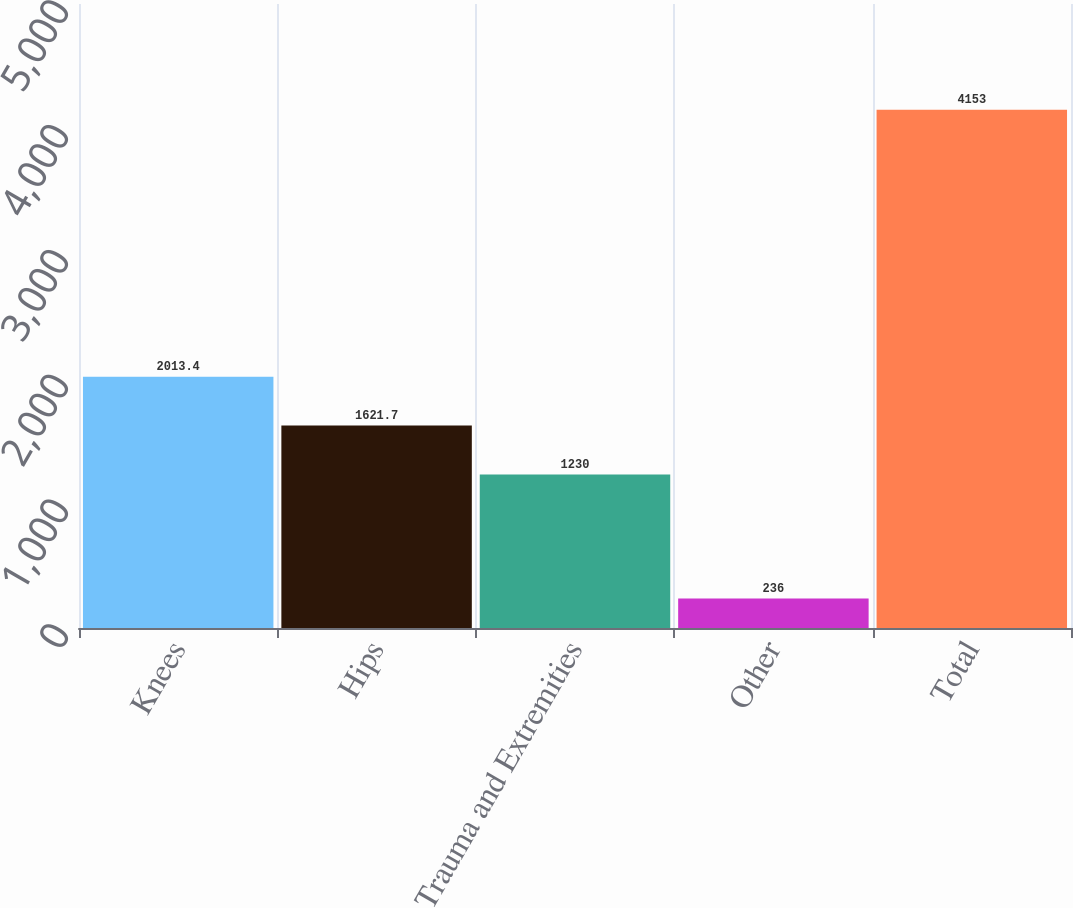Convert chart to OTSL. <chart><loc_0><loc_0><loc_500><loc_500><bar_chart><fcel>Knees<fcel>Hips<fcel>Trauma and Extremities<fcel>Other<fcel>Total<nl><fcel>2013.4<fcel>1621.7<fcel>1230<fcel>236<fcel>4153<nl></chart> 